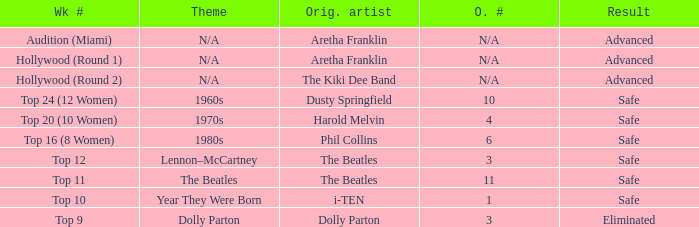What is the order number that has Aretha Franklin as the original artist? N/A, N/A. 